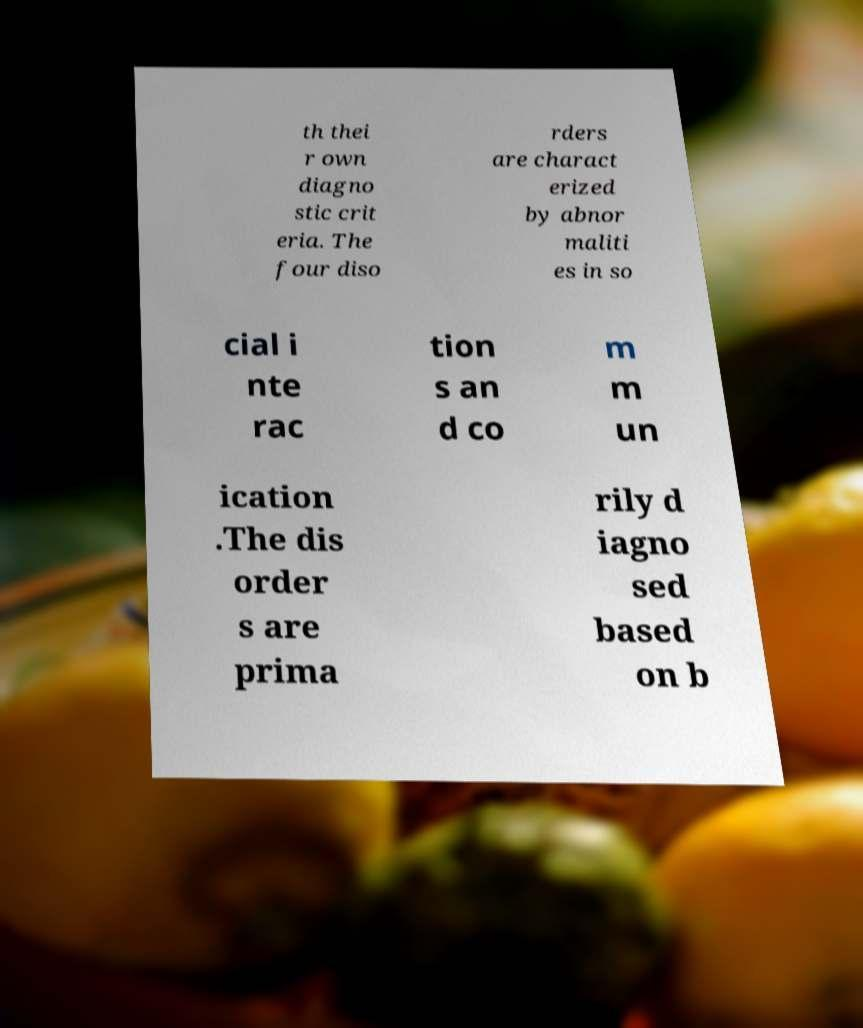Could you extract and type out the text from this image? th thei r own diagno stic crit eria. The four diso rders are charact erized by abnor maliti es in so cial i nte rac tion s an d co m m un ication .The dis order s are prima rily d iagno sed based on b 